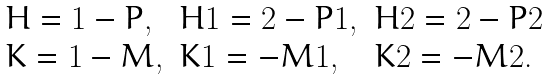<formula> <loc_0><loc_0><loc_500><loc_500>\begin{array} { l l l } H = 1 - P , & H 1 = 2 - P 1 , & H 2 = 2 - P 2 \\ K = 1 - M , & K 1 = - M 1 , & K 2 = - M 2 . \end{array}</formula> 